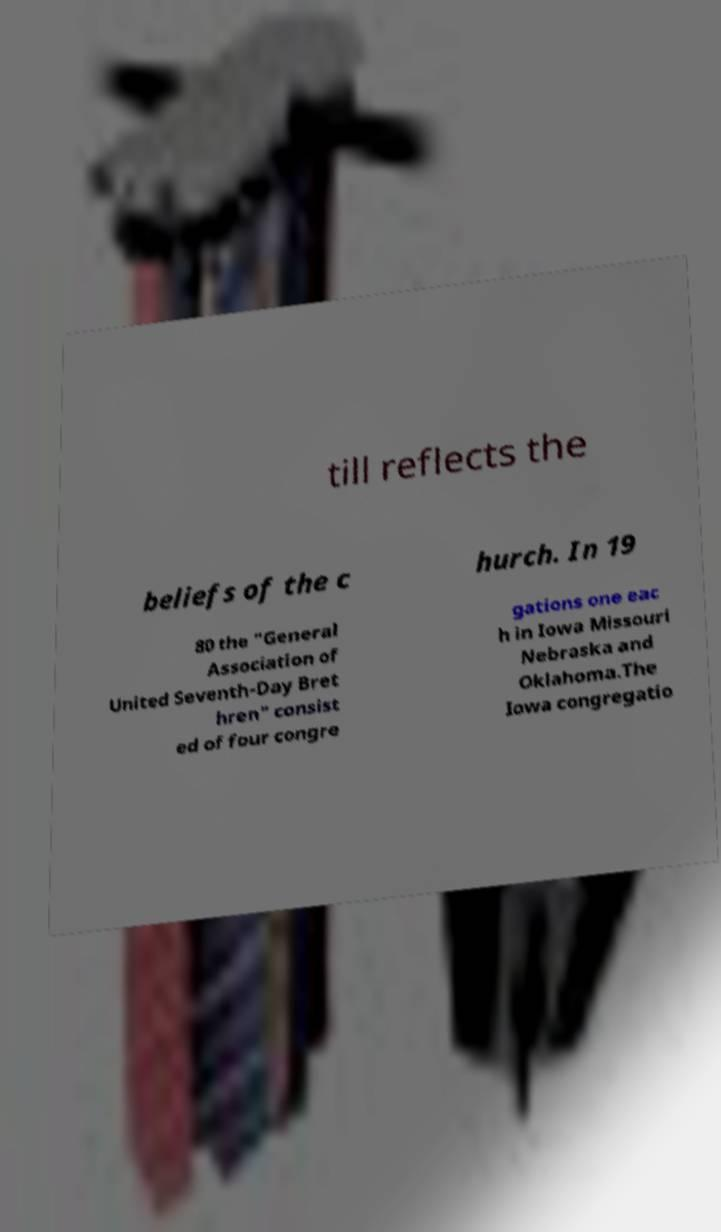There's text embedded in this image that I need extracted. Can you transcribe it verbatim? till reflects the beliefs of the c hurch. In 19 80 the "General Association of United Seventh-Day Bret hren" consist ed of four congre gations one eac h in Iowa Missouri Nebraska and Oklahoma.The Iowa congregatio 